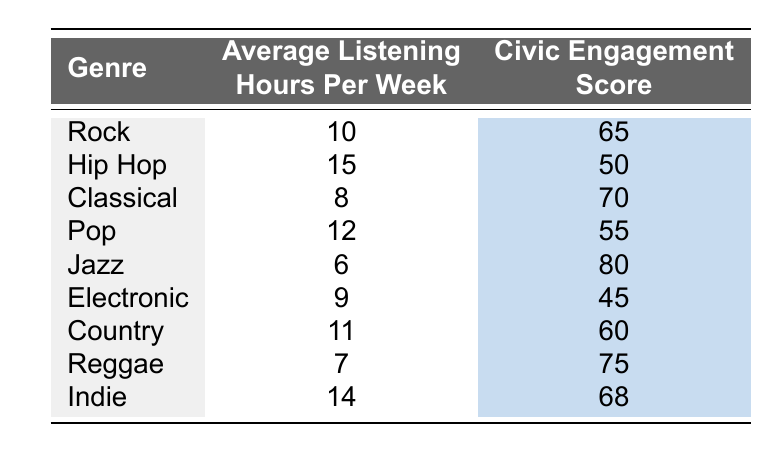What is the civic engagement score for Jazz? The table shows a specific row for the genre Jazz, which is associated with a civic engagement score of 80.
Answer: 80 How many average listening hours per week do people spend listening to Hip Hop? According to the row corresponding to Hip Hop in the table, the average listening hours per week are 15.
Answer: 15 What is the average civic engagement score for Rock and Country combined? First, retrieve the civic engagement scores: Rock (65) and Country (60). Next, calculate the average: (65 + 60) / 2 = 125 / 2 = 62.5.
Answer: 62.5 Is the average listening time for Indie greater than that for Classical? The table shows that Indie has average listening hours of 14, while Classical has 8 hours. Since 14 is greater than 8, the answer is yes.
Answer: Yes Which music genre has the highest civic engagement score? By reviewing the civic engagement scores in the table, Jazz has the highest score of 80, higher than any other genre listed.
Answer: Jazz What is the difference in civic engagement scores between Reggae and Hip Hop? Looking at the table: Reggae has a score of 75, and Hip Hop has a score of 50. The difference is calculated as 75 - 50 = 25.
Answer: 25 Does Pop have a higher average listening time than Electronic? The table indicates Pop has 12 hours and Electronic has 9 hours. Since 12 is greater than 9, the answer is yes.
Answer: Yes If you were to rank the genres by their average listening hours, which genre ranks second? The average listening hours for each genre are: Hip Hop (15), Indie (14), Pop (12), Country (11), Rock (10), Electronic (9), Classical (8), Reggae (7), Jazz (6). After sorting, Indie has the second highest average listening hours.
Answer: Indie What is the total of average listening hours for Rock, Pop, and Jazz? From the table, Rock has 10 hours, Pop has 12 hours, and Jazz has 6 hours. Summing them gives: 10 + 12 + 6 = 28.
Answer: 28 